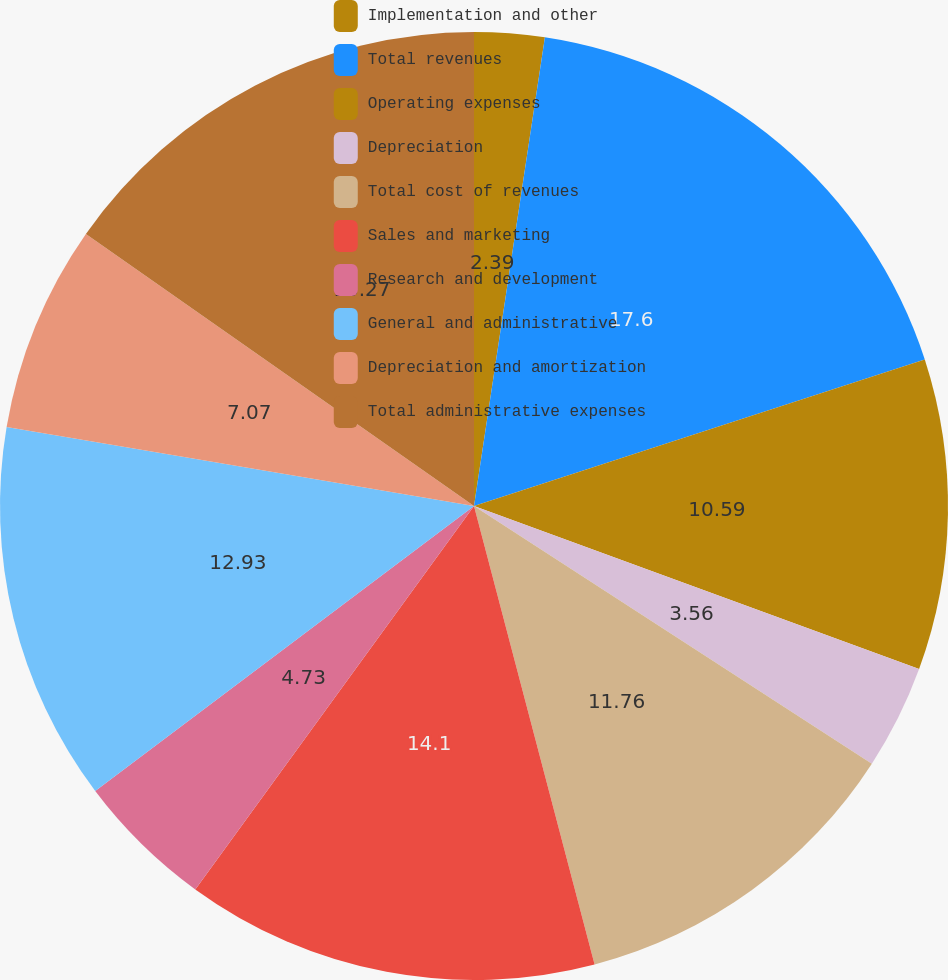Convert chart to OTSL. <chart><loc_0><loc_0><loc_500><loc_500><pie_chart><fcel>Implementation and other<fcel>Total revenues<fcel>Operating expenses<fcel>Depreciation<fcel>Total cost of revenues<fcel>Sales and marketing<fcel>Research and development<fcel>General and administrative<fcel>Depreciation and amortization<fcel>Total administrative expenses<nl><fcel>2.39%<fcel>17.61%<fcel>10.59%<fcel>3.56%<fcel>11.76%<fcel>14.1%<fcel>4.73%<fcel>12.93%<fcel>7.07%<fcel>15.27%<nl></chart> 